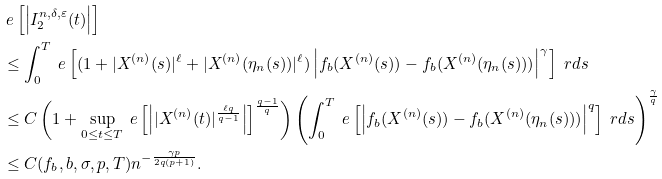Convert formula to latex. <formula><loc_0><loc_0><loc_500><loc_500>& \ e \left [ \left | I _ { 2 } ^ { n , \delta , \varepsilon } ( t ) \right | \right ] \\ & \leq \int _ { 0 } ^ { T } \ e \left [ ( 1 + | X ^ { ( n ) } ( s ) | ^ { \ell } + | X ^ { ( n ) } ( \eta _ { n } ( s ) ) | ^ { \ell } ) \left | f _ { b } ( X ^ { ( n ) } ( s ) ) - f _ { b } ( X ^ { ( n ) } ( \eta _ { n } ( s ) ) ) \right | ^ { \gamma } \right ] \ r d s \\ & \leq C \left ( 1 + \sup _ { 0 \leq t \leq T } \ e \left [ \left | | X ^ { ( n ) } ( t ) | ^ { \frac { \ell q } { q - 1 } } \right | \right ] ^ { \frac { q - 1 } { q } } \right ) \left ( \int _ { 0 } ^ { T } \ e \left [ \left | f _ { b } ( X ^ { ( n ) } ( s ) ) - f _ { b } ( X ^ { ( n ) } ( \eta _ { n } ( s ) ) ) \right | ^ { q } \right ] \ r d s \right ) ^ { \frac { \gamma } { q } } \\ & \leq C ( f _ { b } , b , \sigma , p , T ) n ^ { - \frac { \gamma p } { 2 q ( p + 1 ) } } .</formula> 